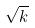<formula> <loc_0><loc_0><loc_500><loc_500>\sqrt { k }</formula> 